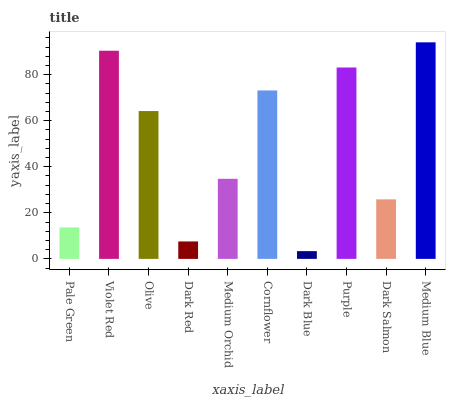Is Dark Blue the minimum?
Answer yes or no. Yes. Is Medium Blue the maximum?
Answer yes or no. Yes. Is Violet Red the minimum?
Answer yes or no. No. Is Violet Red the maximum?
Answer yes or no. No. Is Violet Red greater than Pale Green?
Answer yes or no. Yes. Is Pale Green less than Violet Red?
Answer yes or no. Yes. Is Pale Green greater than Violet Red?
Answer yes or no. No. Is Violet Red less than Pale Green?
Answer yes or no. No. Is Olive the high median?
Answer yes or no. Yes. Is Medium Orchid the low median?
Answer yes or no. Yes. Is Medium Orchid the high median?
Answer yes or no. No. Is Medium Blue the low median?
Answer yes or no. No. 